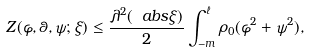Convert formula to latex. <formula><loc_0><loc_0><loc_500><loc_500>Z ( \varphi , \theta , \psi ; \xi ) \leq \frac { \lambda ^ { 2 } ( \ a b s { \xi } ) } { 2 } \int _ { - m } ^ { \ell } \rho _ { 0 } ( \varphi ^ { 2 } + \psi ^ { 2 } ) ,</formula> 